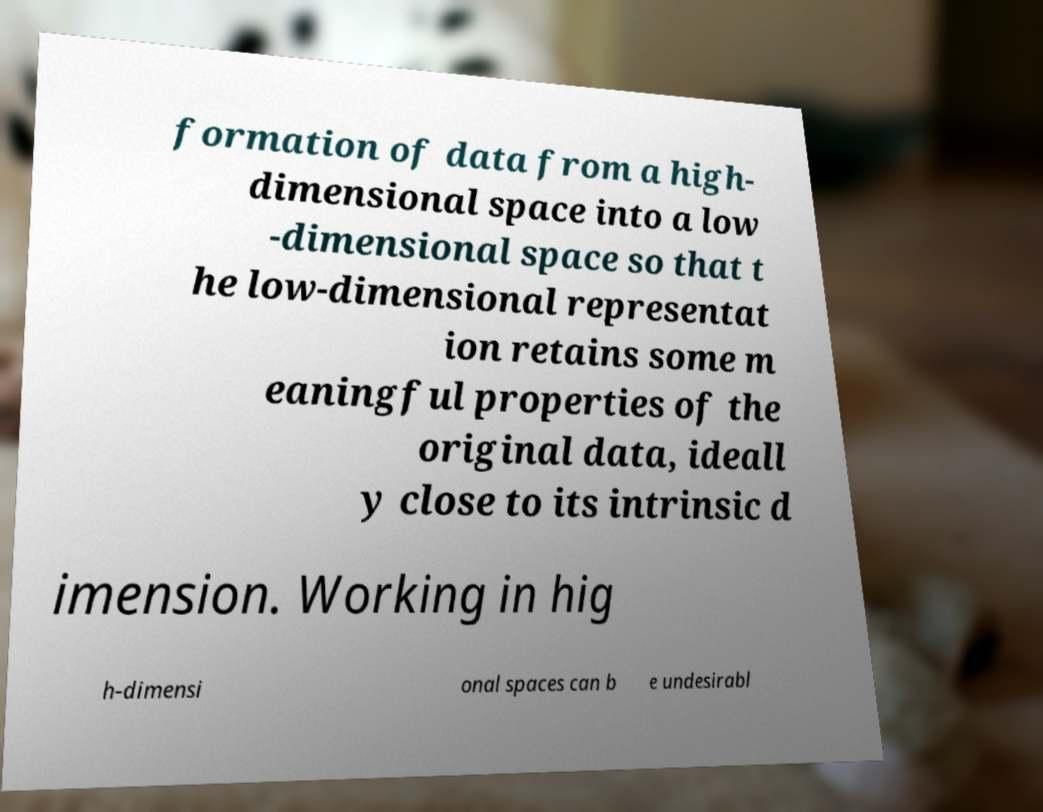I need the written content from this picture converted into text. Can you do that? formation of data from a high- dimensional space into a low -dimensional space so that t he low-dimensional representat ion retains some m eaningful properties of the original data, ideall y close to its intrinsic d imension. Working in hig h-dimensi onal spaces can b e undesirabl 